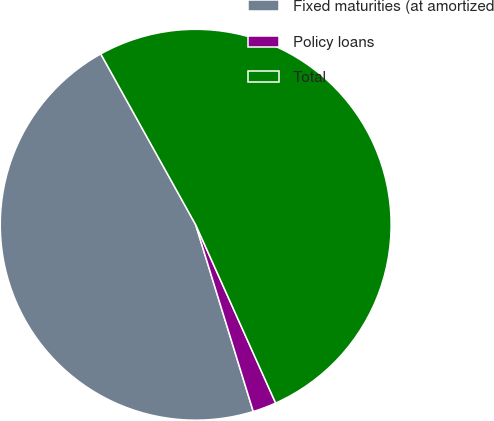Convert chart. <chart><loc_0><loc_0><loc_500><loc_500><pie_chart><fcel>Fixed maturities (at amortized<fcel>Policy loans<fcel>Total<nl><fcel>46.69%<fcel>1.95%<fcel>51.36%<nl></chart> 